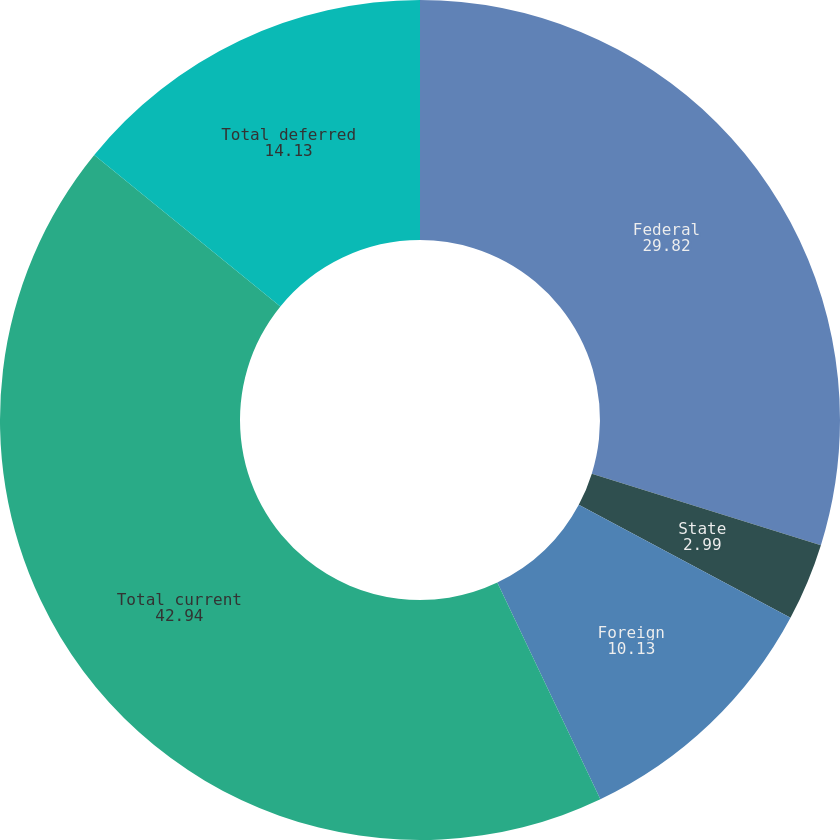Convert chart. <chart><loc_0><loc_0><loc_500><loc_500><pie_chart><fcel>Federal<fcel>State<fcel>Foreign<fcel>Total current<fcel>Total deferred<nl><fcel>29.82%<fcel>2.99%<fcel>10.13%<fcel>42.94%<fcel>14.13%<nl></chart> 